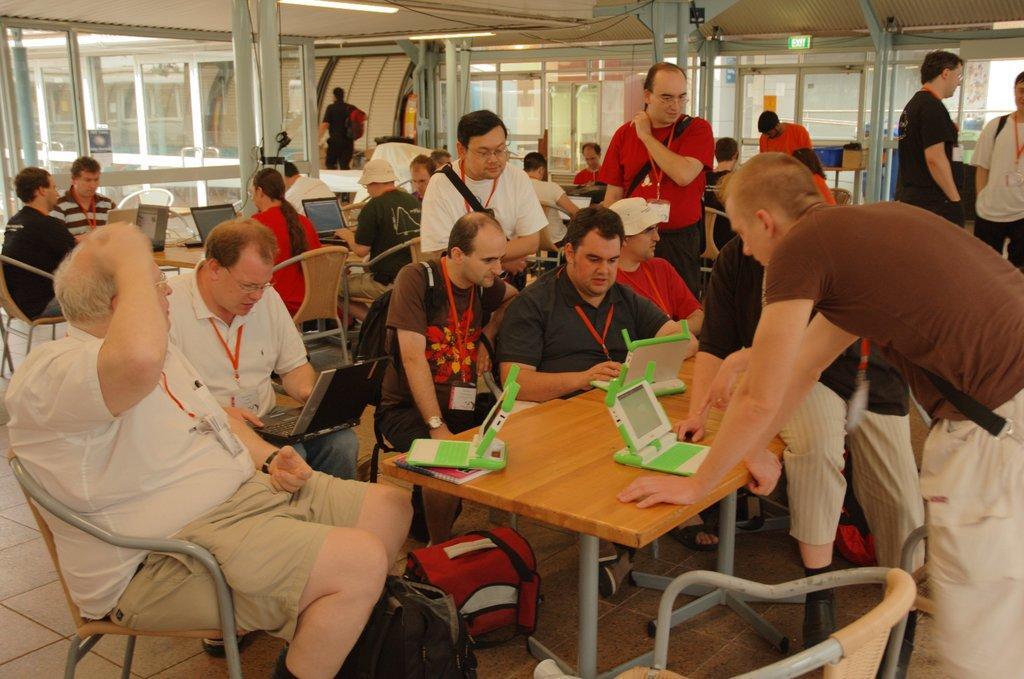In one or two sentences, can you explain what this image depicts? In this image i can see group of people sitting on chairs in front of tables, On the tables i can see laptops and few other electronic gadgets. In the background i can see ceiling , a board , few persons standing and the glass window through which i can see a building. 